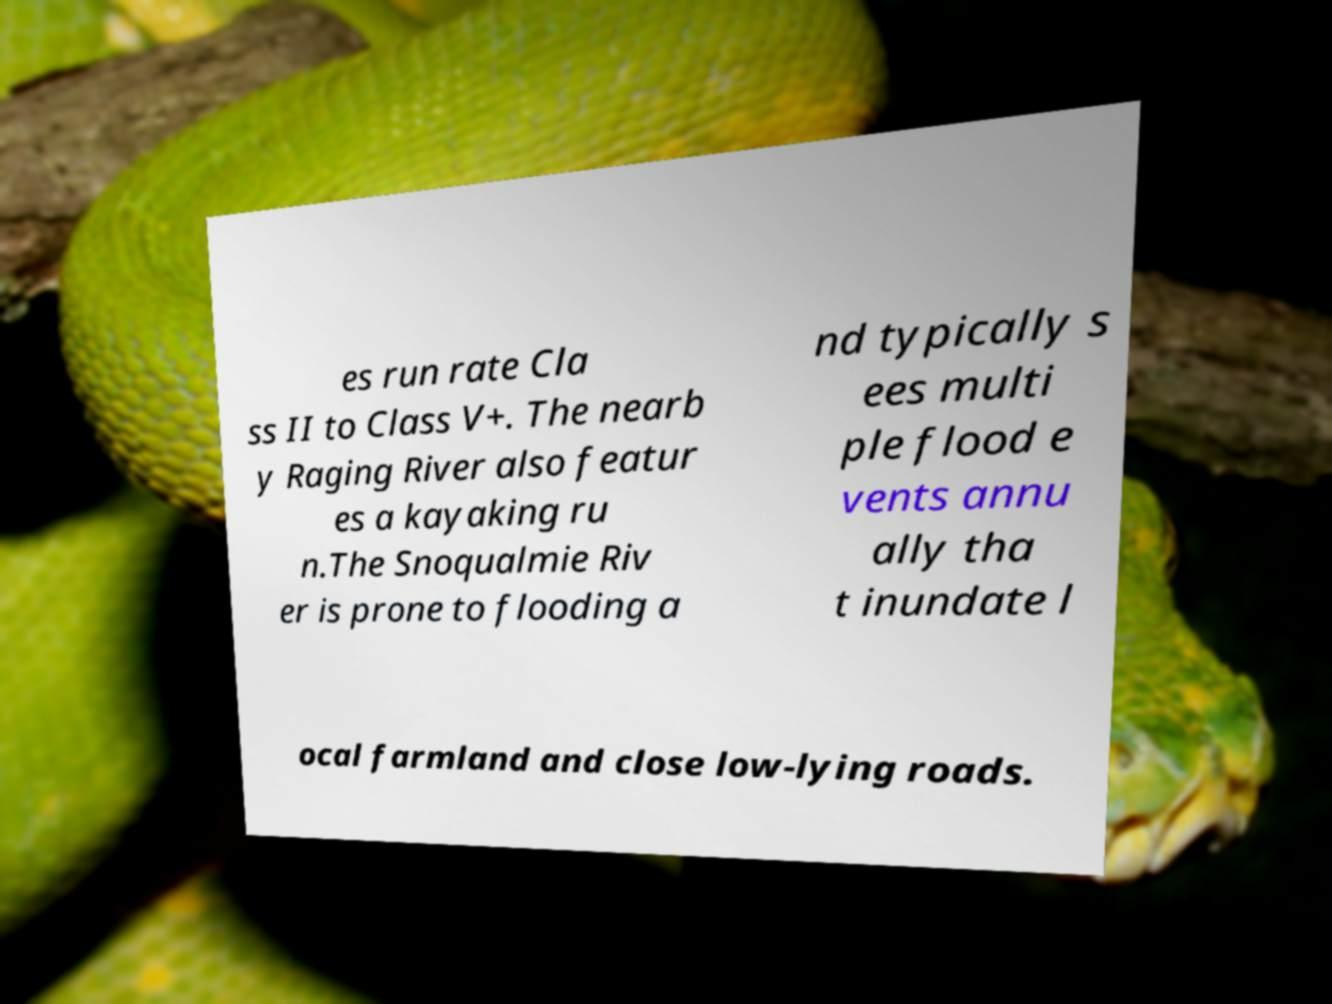For documentation purposes, I need the text within this image transcribed. Could you provide that? es run rate Cla ss II to Class V+. The nearb y Raging River also featur es a kayaking ru n.The Snoqualmie Riv er is prone to flooding a nd typically s ees multi ple flood e vents annu ally tha t inundate l ocal farmland and close low-lying roads. 